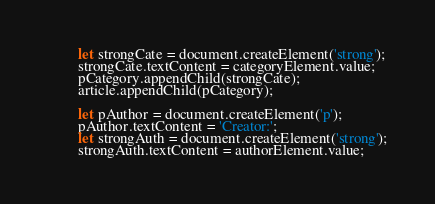Convert code to text. <code><loc_0><loc_0><loc_500><loc_500><_JavaScript_>        let strongCate = document.createElement('strong');
        strongCate.textContent = categoryElement.value;
        pCategory.appendChild(strongCate);
        article.appendChild(pCategory);

        let pAuthor = document.createElement('p');
        pAuthor.textContent = 'Creator:';
        let strongAuth = document.createElement('strong');
        strongAuth.textContent = authorElement.value;</code> 